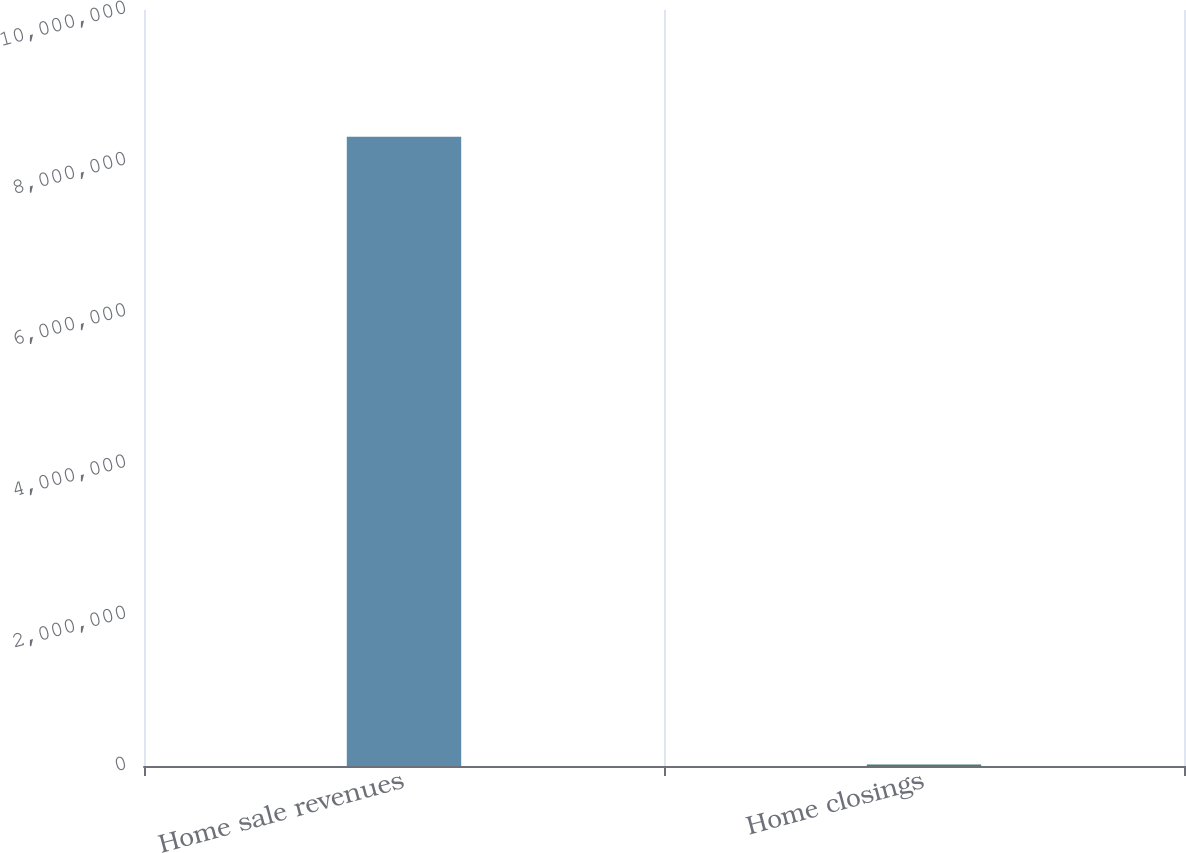Convert chart to OTSL. <chart><loc_0><loc_0><loc_500><loc_500><bar_chart><fcel>Home sale revenues<fcel>Home closings<nl><fcel>8.32398e+06<fcel>21052<nl></chart> 